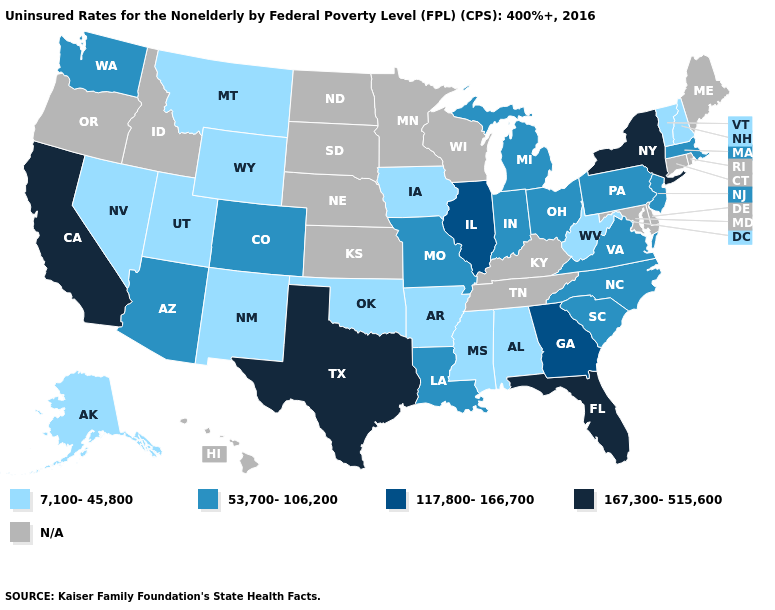What is the highest value in the Northeast ?
Answer briefly. 167,300-515,600. Name the states that have a value in the range 167,300-515,600?
Keep it brief. California, Florida, New York, Texas. How many symbols are there in the legend?
Concise answer only. 5. Is the legend a continuous bar?
Write a very short answer. No. How many symbols are there in the legend?
Write a very short answer. 5. Name the states that have a value in the range N/A?
Answer briefly. Connecticut, Delaware, Hawaii, Idaho, Kansas, Kentucky, Maine, Maryland, Minnesota, Nebraska, North Dakota, Oregon, Rhode Island, South Dakota, Tennessee, Wisconsin. What is the value of Alaska?
Answer briefly. 7,100-45,800. Name the states that have a value in the range 53,700-106,200?
Concise answer only. Arizona, Colorado, Indiana, Louisiana, Massachusetts, Michigan, Missouri, New Jersey, North Carolina, Ohio, Pennsylvania, South Carolina, Virginia, Washington. Name the states that have a value in the range 117,800-166,700?
Be succinct. Georgia, Illinois. What is the highest value in states that border Iowa?
Be succinct. 117,800-166,700. Name the states that have a value in the range N/A?
Be succinct. Connecticut, Delaware, Hawaii, Idaho, Kansas, Kentucky, Maine, Maryland, Minnesota, Nebraska, North Dakota, Oregon, Rhode Island, South Dakota, Tennessee, Wisconsin. Name the states that have a value in the range 7,100-45,800?
Be succinct. Alabama, Alaska, Arkansas, Iowa, Mississippi, Montana, Nevada, New Hampshire, New Mexico, Oklahoma, Utah, Vermont, West Virginia, Wyoming. What is the value of Virginia?
Give a very brief answer. 53,700-106,200. What is the value of New Jersey?
Short answer required. 53,700-106,200. 